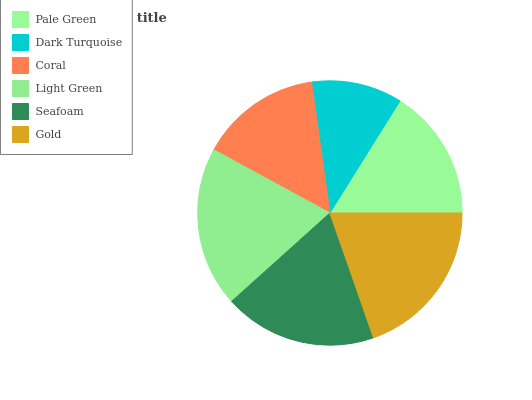Is Dark Turquoise the minimum?
Answer yes or no. Yes. Is Gold the maximum?
Answer yes or no. Yes. Is Coral the minimum?
Answer yes or no. No. Is Coral the maximum?
Answer yes or no. No. Is Coral greater than Dark Turquoise?
Answer yes or no. Yes. Is Dark Turquoise less than Coral?
Answer yes or no. Yes. Is Dark Turquoise greater than Coral?
Answer yes or no. No. Is Coral less than Dark Turquoise?
Answer yes or no. No. Is Seafoam the high median?
Answer yes or no. Yes. Is Pale Green the low median?
Answer yes or no. Yes. Is Pale Green the high median?
Answer yes or no. No. Is Dark Turquoise the low median?
Answer yes or no. No. 